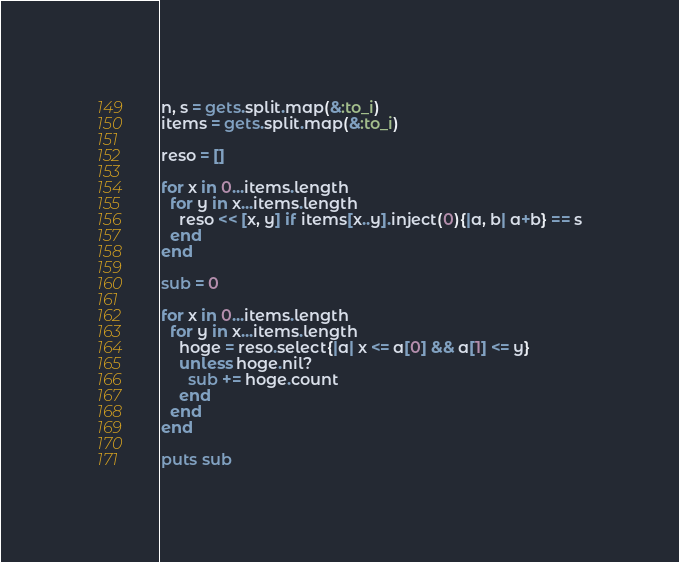Convert code to text. <code><loc_0><loc_0><loc_500><loc_500><_Ruby_>n, s = gets.split.map(&:to_i)
items = gets.split.map(&:to_i)

reso = []

for x in 0...items.length
  for y in x...items.length
    reso << [x, y] if items[x..y].inject(0){|a, b| a+b} == s
  end
end

sub = 0

for x in 0...items.length
  for y in x...items.length
    hoge = reso.select{|a| x <= a[0] && a[1] <= y}
    unless hoge.nil?
      sub += hoge.count
    end
  end
end

puts sub
</code> 